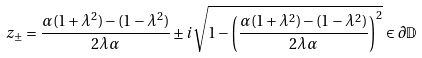<formula> <loc_0><loc_0><loc_500><loc_500>z _ { \pm } = \frac { \alpha ( 1 + \lambda ^ { 2 } ) - ( 1 - \lambda ^ { 2 } ) } { 2 \lambda \alpha } \pm i \sqrt { 1 - \left ( \frac { \alpha ( 1 + \lambda ^ { 2 } ) - ( 1 - \lambda ^ { 2 } ) } { 2 \lambda \alpha } \right ) ^ { 2 } } \in \partial \mathbb { D }</formula> 